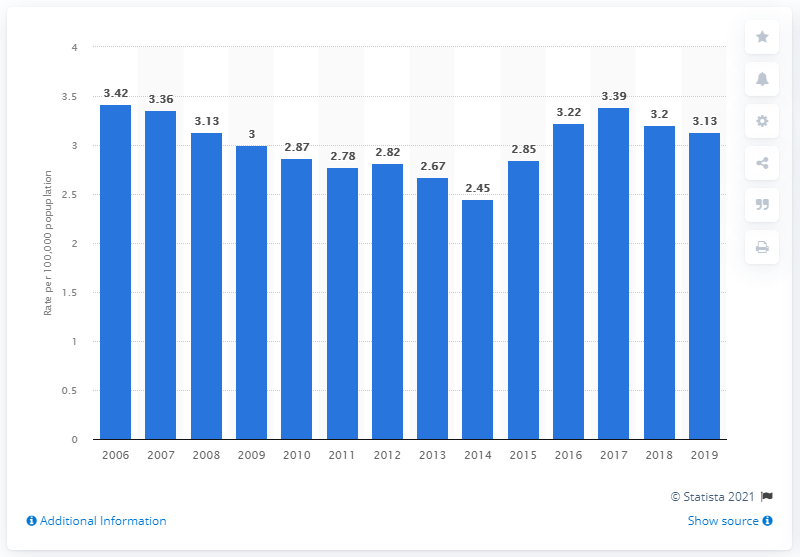Outline some significant characteristics in this image. In 2019, there were approximately 3.13 homicides by firearm committed per 100,000 residents in the United States. 